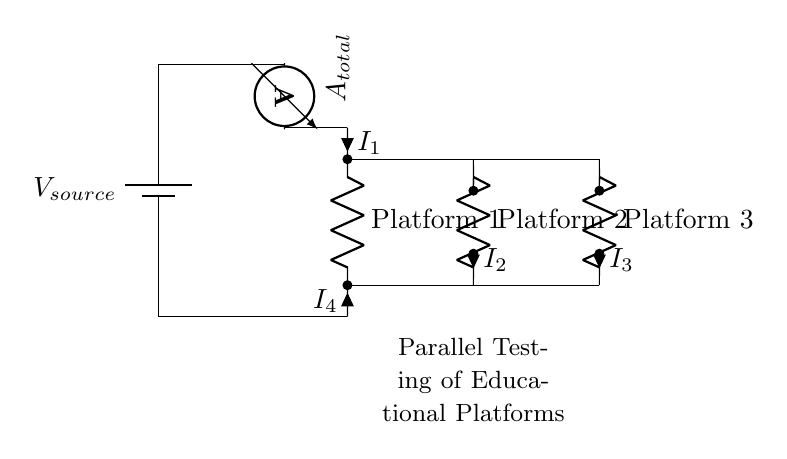What is the total current in the circuit? The total current, indicated by the ammeter, is the sum of the currents through each of the three platforms, represented as I1, I2, and I3. To find this value, one would typically refer to measurements or simulation results specific to the values of these currents.
Answer: A total current value What components are connected in parallel? The components connected in parallel are Platform 1, Platform 2, and Platform 3. These platforms are arranged such that they share the same voltage across them and provide individual pathways for current flow.
Answer: Platform 1, Platform 2, Platform 3 What is the role of the voltage source? The voltage source provides the necessary electrical potential (voltage) required for the current to flow through the parallel connections, enabling the testing of the software platforms.
Answer: Power supply How many platforms are being tested simultaneously? The circuit diagram indicates that three platforms are being tested simultaneously, as there are three separate resistive components designated as Platform 1, Platform 2, and Platform 3.
Answer: Three Which current is flowing through Platform 2? The current flowing through Platform 2 is denoted as I2. This specific current can be read from the circuit diagram labeled next to the resistor for Platform 2, showing the current that flows through this path.
Answer: I2 What is the voltage across each platform? The voltage across each platform remains the same as that of the voltage source due to the nature of parallel circuits, where each component experiences the same potential difference. The voltage value is typically defined by the voltage source.
Answer: Same as Vsource 